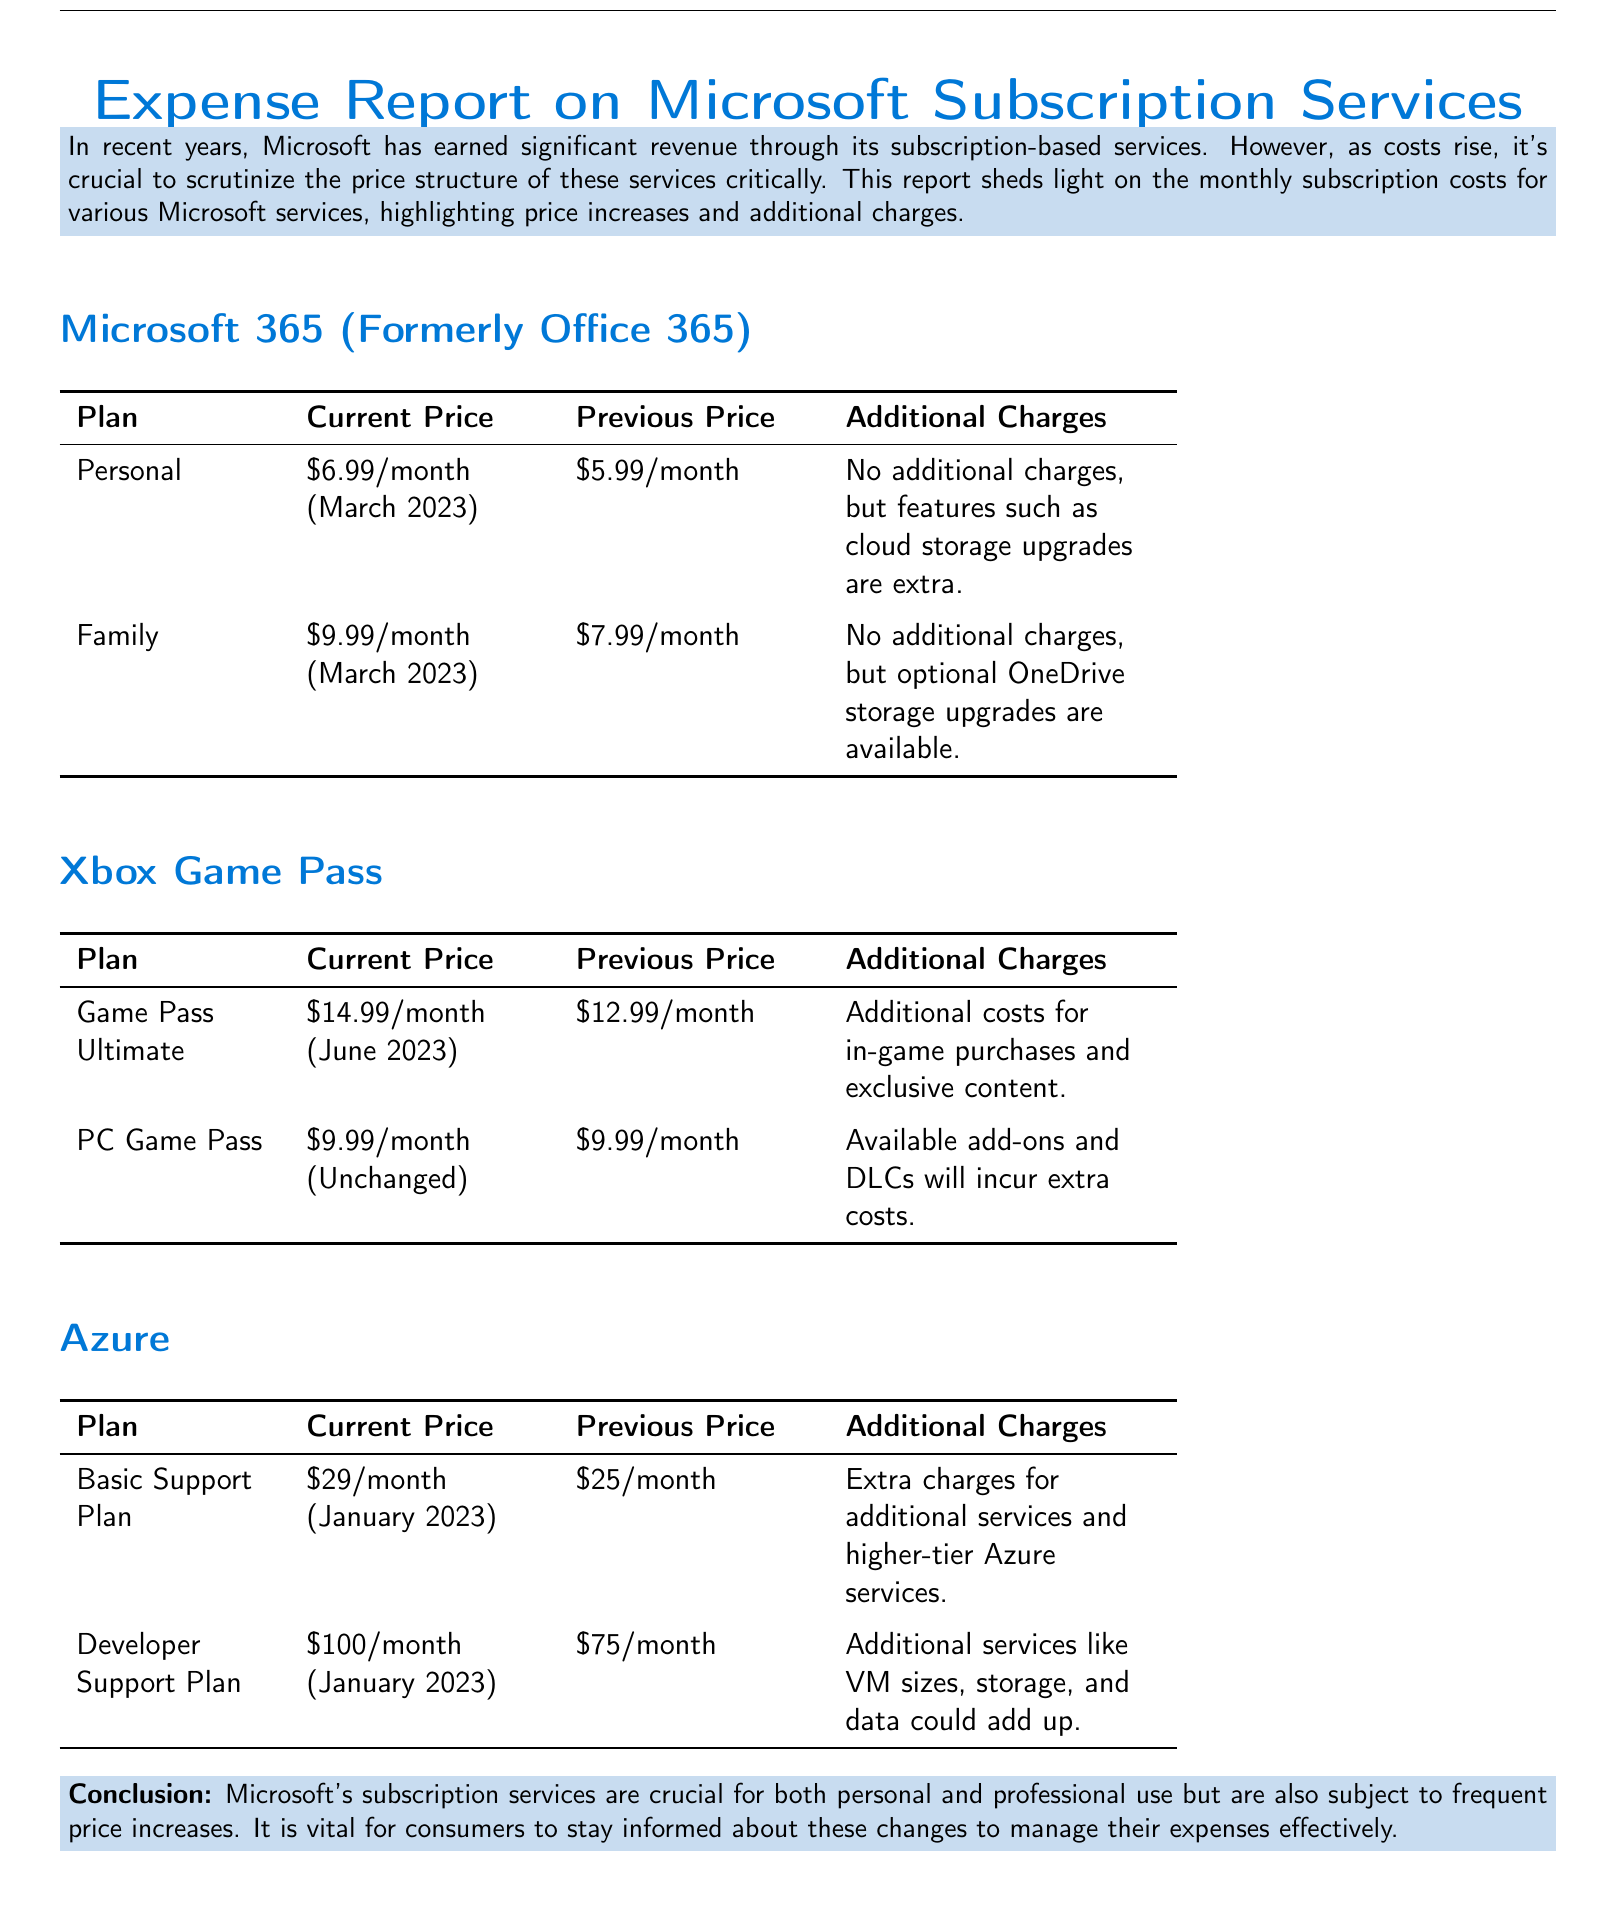What is the current price of Microsoft 365 Personal? The document states that the current price of Microsoft 365 Personal is $6.99/month (March 2023).
Answer: $6.99/month (March 2023) What was the previous price of the Family plan? According to the report, the previous price of the Family plan was $7.99/month.
Answer: $7.99/month What are the additional charges for Azure's Basic Support Plan? The document mentions that there are extra charges for additional services and higher-tier Azure services.
Answer: Extra charges for additional services and higher-tier Azure services Which Xbox Game Pass plan had a price increase? The Game Pass Ultimate plan had a price increase from $12.99/month to $14.99/month.
Answer: Game Pass Ultimate How much did the Developer Support Plan increase in price? The Developer Support Plan increased from $75/month to $100/month, which is a $25 increase.
Answer: $25 What is the additional charge for the Game Pass Ultimate plan? The report highlights that there are additional costs for in-game purchases and exclusive content.
Answer: In-game purchases and exclusive content What is the document primarily about? The document primarily discusses the breakdown of monthly subscription costs for various Microsoft services.
Answer: Breakdown of monthly subscription costs What month was the Family plan's current price last updated? The document states that the current price of the Family plan was updated in March 2023.
Answer: March 2023 What type of report is this document classified as? The document is classified as an expense report on Microsoft subscription services.
Answer: Expense report 